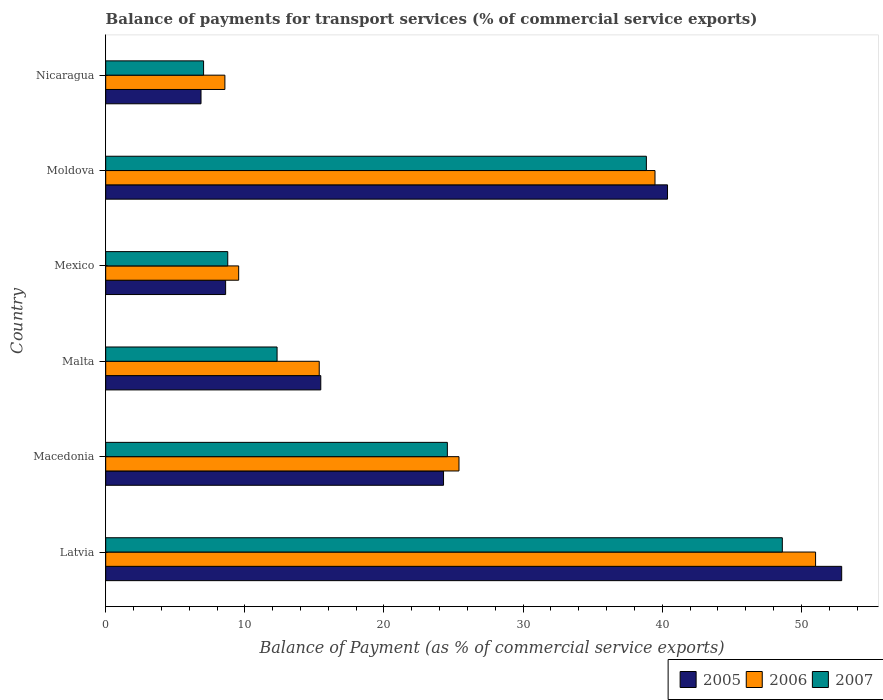How many different coloured bars are there?
Keep it short and to the point. 3. How many groups of bars are there?
Offer a very short reply. 6. Are the number of bars on each tick of the Y-axis equal?
Offer a terse response. Yes. How many bars are there on the 3rd tick from the top?
Your answer should be very brief. 3. How many bars are there on the 6th tick from the bottom?
Provide a succinct answer. 3. What is the balance of payments for transport services in 2006 in Mexico?
Your answer should be compact. 9.56. Across all countries, what is the maximum balance of payments for transport services in 2006?
Provide a short and direct response. 51.02. Across all countries, what is the minimum balance of payments for transport services in 2006?
Ensure brevity in your answer.  8.57. In which country was the balance of payments for transport services in 2005 maximum?
Offer a terse response. Latvia. In which country was the balance of payments for transport services in 2007 minimum?
Offer a terse response. Nicaragua. What is the total balance of payments for transport services in 2006 in the graph?
Give a very brief answer. 149.37. What is the difference between the balance of payments for transport services in 2007 in Malta and that in Moldova?
Offer a terse response. -26.54. What is the difference between the balance of payments for transport services in 2005 in Macedonia and the balance of payments for transport services in 2006 in Mexico?
Ensure brevity in your answer.  14.72. What is the average balance of payments for transport services in 2007 per country?
Your answer should be compact. 23.36. What is the difference between the balance of payments for transport services in 2006 and balance of payments for transport services in 2007 in Malta?
Offer a terse response. 3.03. What is the ratio of the balance of payments for transport services in 2007 in Latvia to that in Macedonia?
Provide a short and direct response. 1.98. Is the difference between the balance of payments for transport services in 2006 in Macedonia and Moldova greater than the difference between the balance of payments for transport services in 2007 in Macedonia and Moldova?
Provide a succinct answer. Yes. What is the difference between the highest and the second highest balance of payments for transport services in 2006?
Ensure brevity in your answer.  11.54. What is the difference between the highest and the lowest balance of payments for transport services in 2006?
Offer a very short reply. 42.46. Is the sum of the balance of payments for transport services in 2006 in Latvia and Moldova greater than the maximum balance of payments for transport services in 2005 across all countries?
Offer a very short reply. Yes. What does the 2nd bar from the bottom in Latvia represents?
Provide a succinct answer. 2006. How many bars are there?
Make the answer very short. 18. What is the difference between two consecutive major ticks on the X-axis?
Offer a very short reply. 10. Are the values on the major ticks of X-axis written in scientific E-notation?
Offer a terse response. No. Does the graph contain any zero values?
Give a very brief answer. No. Where does the legend appear in the graph?
Give a very brief answer. Bottom right. How many legend labels are there?
Keep it short and to the point. 3. How are the legend labels stacked?
Your answer should be compact. Horizontal. What is the title of the graph?
Offer a terse response. Balance of payments for transport services (% of commercial service exports). What is the label or title of the X-axis?
Your response must be concise. Balance of Payment (as % of commercial service exports). What is the label or title of the Y-axis?
Ensure brevity in your answer.  Country. What is the Balance of Payment (as % of commercial service exports) of 2005 in Latvia?
Give a very brief answer. 52.9. What is the Balance of Payment (as % of commercial service exports) of 2006 in Latvia?
Offer a terse response. 51.02. What is the Balance of Payment (as % of commercial service exports) of 2007 in Latvia?
Make the answer very short. 48.63. What is the Balance of Payment (as % of commercial service exports) of 2005 in Macedonia?
Keep it short and to the point. 24.28. What is the Balance of Payment (as % of commercial service exports) of 2006 in Macedonia?
Give a very brief answer. 25.39. What is the Balance of Payment (as % of commercial service exports) in 2007 in Macedonia?
Your answer should be compact. 24.56. What is the Balance of Payment (as % of commercial service exports) in 2005 in Malta?
Provide a succinct answer. 15.46. What is the Balance of Payment (as % of commercial service exports) in 2006 in Malta?
Offer a very short reply. 15.35. What is the Balance of Payment (as % of commercial service exports) of 2007 in Malta?
Offer a terse response. 12.32. What is the Balance of Payment (as % of commercial service exports) of 2005 in Mexico?
Provide a short and direct response. 8.62. What is the Balance of Payment (as % of commercial service exports) in 2006 in Mexico?
Your response must be concise. 9.56. What is the Balance of Payment (as % of commercial service exports) of 2007 in Mexico?
Your response must be concise. 8.77. What is the Balance of Payment (as % of commercial service exports) of 2005 in Moldova?
Your answer should be compact. 40.38. What is the Balance of Payment (as % of commercial service exports) of 2006 in Moldova?
Your answer should be very brief. 39.48. What is the Balance of Payment (as % of commercial service exports) of 2007 in Moldova?
Offer a very short reply. 38.86. What is the Balance of Payment (as % of commercial service exports) in 2005 in Nicaragua?
Offer a terse response. 6.85. What is the Balance of Payment (as % of commercial service exports) of 2006 in Nicaragua?
Give a very brief answer. 8.57. What is the Balance of Payment (as % of commercial service exports) of 2007 in Nicaragua?
Keep it short and to the point. 7.04. Across all countries, what is the maximum Balance of Payment (as % of commercial service exports) in 2005?
Ensure brevity in your answer.  52.9. Across all countries, what is the maximum Balance of Payment (as % of commercial service exports) in 2006?
Keep it short and to the point. 51.02. Across all countries, what is the maximum Balance of Payment (as % of commercial service exports) of 2007?
Make the answer very short. 48.63. Across all countries, what is the minimum Balance of Payment (as % of commercial service exports) in 2005?
Offer a very short reply. 6.85. Across all countries, what is the minimum Balance of Payment (as % of commercial service exports) of 2006?
Your answer should be compact. 8.57. Across all countries, what is the minimum Balance of Payment (as % of commercial service exports) in 2007?
Your answer should be compact. 7.04. What is the total Balance of Payment (as % of commercial service exports) of 2005 in the graph?
Your answer should be very brief. 148.49. What is the total Balance of Payment (as % of commercial service exports) of 2006 in the graph?
Keep it short and to the point. 149.37. What is the total Balance of Payment (as % of commercial service exports) of 2007 in the graph?
Provide a short and direct response. 140.18. What is the difference between the Balance of Payment (as % of commercial service exports) in 2005 in Latvia and that in Macedonia?
Provide a short and direct response. 28.62. What is the difference between the Balance of Payment (as % of commercial service exports) in 2006 in Latvia and that in Macedonia?
Offer a very short reply. 25.63. What is the difference between the Balance of Payment (as % of commercial service exports) of 2007 in Latvia and that in Macedonia?
Ensure brevity in your answer.  24.07. What is the difference between the Balance of Payment (as % of commercial service exports) of 2005 in Latvia and that in Malta?
Your response must be concise. 37.44. What is the difference between the Balance of Payment (as % of commercial service exports) of 2006 in Latvia and that in Malta?
Offer a terse response. 35.67. What is the difference between the Balance of Payment (as % of commercial service exports) of 2007 in Latvia and that in Malta?
Give a very brief answer. 36.31. What is the difference between the Balance of Payment (as % of commercial service exports) in 2005 in Latvia and that in Mexico?
Your answer should be very brief. 44.28. What is the difference between the Balance of Payment (as % of commercial service exports) of 2006 in Latvia and that in Mexico?
Keep it short and to the point. 41.47. What is the difference between the Balance of Payment (as % of commercial service exports) in 2007 in Latvia and that in Mexico?
Offer a very short reply. 39.86. What is the difference between the Balance of Payment (as % of commercial service exports) of 2005 in Latvia and that in Moldova?
Your response must be concise. 12.52. What is the difference between the Balance of Payment (as % of commercial service exports) of 2006 in Latvia and that in Moldova?
Provide a succinct answer. 11.54. What is the difference between the Balance of Payment (as % of commercial service exports) of 2007 in Latvia and that in Moldova?
Offer a very short reply. 9.77. What is the difference between the Balance of Payment (as % of commercial service exports) of 2005 in Latvia and that in Nicaragua?
Your answer should be very brief. 46.05. What is the difference between the Balance of Payment (as % of commercial service exports) in 2006 in Latvia and that in Nicaragua?
Your answer should be compact. 42.46. What is the difference between the Balance of Payment (as % of commercial service exports) of 2007 in Latvia and that in Nicaragua?
Ensure brevity in your answer.  41.6. What is the difference between the Balance of Payment (as % of commercial service exports) of 2005 in Macedonia and that in Malta?
Ensure brevity in your answer.  8.82. What is the difference between the Balance of Payment (as % of commercial service exports) of 2006 in Macedonia and that in Malta?
Your response must be concise. 10.04. What is the difference between the Balance of Payment (as % of commercial service exports) of 2007 in Macedonia and that in Malta?
Keep it short and to the point. 12.24. What is the difference between the Balance of Payment (as % of commercial service exports) of 2005 in Macedonia and that in Mexico?
Give a very brief answer. 15.66. What is the difference between the Balance of Payment (as % of commercial service exports) of 2006 in Macedonia and that in Mexico?
Provide a short and direct response. 15.84. What is the difference between the Balance of Payment (as % of commercial service exports) in 2007 in Macedonia and that in Mexico?
Keep it short and to the point. 15.78. What is the difference between the Balance of Payment (as % of commercial service exports) in 2005 in Macedonia and that in Moldova?
Ensure brevity in your answer.  -16.1. What is the difference between the Balance of Payment (as % of commercial service exports) of 2006 in Macedonia and that in Moldova?
Ensure brevity in your answer.  -14.09. What is the difference between the Balance of Payment (as % of commercial service exports) in 2007 in Macedonia and that in Moldova?
Provide a short and direct response. -14.3. What is the difference between the Balance of Payment (as % of commercial service exports) in 2005 in Macedonia and that in Nicaragua?
Keep it short and to the point. 17.43. What is the difference between the Balance of Payment (as % of commercial service exports) in 2006 in Macedonia and that in Nicaragua?
Provide a short and direct response. 16.83. What is the difference between the Balance of Payment (as % of commercial service exports) of 2007 in Macedonia and that in Nicaragua?
Offer a terse response. 17.52. What is the difference between the Balance of Payment (as % of commercial service exports) in 2005 in Malta and that in Mexico?
Offer a terse response. 6.84. What is the difference between the Balance of Payment (as % of commercial service exports) in 2006 in Malta and that in Mexico?
Your answer should be very brief. 5.79. What is the difference between the Balance of Payment (as % of commercial service exports) of 2007 in Malta and that in Mexico?
Give a very brief answer. 3.54. What is the difference between the Balance of Payment (as % of commercial service exports) of 2005 in Malta and that in Moldova?
Provide a short and direct response. -24.92. What is the difference between the Balance of Payment (as % of commercial service exports) of 2006 in Malta and that in Moldova?
Your answer should be very brief. -24.13. What is the difference between the Balance of Payment (as % of commercial service exports) in 2007 in Malta and that in Moldova?
Keep it short and to the point. -26.54. What is the difference between the Balance of Payment (as % of commercial service exports) of 2005 in Malta and that in Nicaragua?
Your answer should be compact. 8.61. What is the difference between the Balance of Payment (as % of commercial service exports) of 2006 in Malta and that in Nicaragua?
Your response must be concise. 6.78. What is the difference between the Balance of Payment (as % of commercial service exports) in 2007 in Malta and that in Nicaragua?
Your answer should be very brief. 5.28. What is the difference between the Balance of Payment (as % of commercial service exports) of 2005 in Mexico and that in Moldova?
Give a very brief answer. -31.76. What is the difference between the Balance of Payment (as % of commercial service exports) in 2006 in Mexico and that in Moldova?
Provide a succinct answer. -29.92. What is the difference between the Balance of Payment (as % of commercial service exports) of 2007 in Mexico and that in Moldova?
Your response must be concise. -30.09. What is the difference between the Balance of Payment (as % of commercial service exports) of 2005 in Mexico and that in Nicaragua?
Your answer should be very brief. 1.77. What is the difference between the Balance of Payment (as % of commercial service exports) in 2006 in Mexico and that in Nicaragua?
Offer a very short reply. 0.99. What is the difference between the Balance of Payment (as % of commercial service exports) of 2007 in Mexico and that in Nicaragua?
Ensure brevity in your answer.  1.74. What is the difference between the Balance of Payment (as % of commercial service exports) of 2005 in Moldova and that in Nicaragua?
Offer a very short reply. 33.53. What is the difference between the Balance of Payment (as % of commercial service exports) in 2006 in Moldova and that in Nicaragua?
Make the answer very short. 30.91. What is the difference between the Balance of Payment (as % of commercial service exports) of 2007 in Moldova and that in Nicaragua?
Keep it short and to the point. 31.83. What is the difference between the Balance of Payment (as % of commercial service exports) of 2005 in Latvia and the Balance of Payment (as % of commercial service exports) of 2006 in Macedonia?
Provide a short and direct response. 27.51. What is the difference between the Balance of Payment (as % of commercial service exports) in 2005 in Latvia and the Balance of Payment (as % of commercial service exports) in 2007 in Macedonia?
Ensure brevity in your answer.  28.34. What is the difference between the Balance of Payment (as % of commercial service exports) of 2006 in Latvia and the Balance of Payment (as % of commercial service exports) of 2007 in Macedonia?
Provide a short and direct response. 26.47. What is the difference between the Balance of Payment (as % of commercial service exports) in 2005 in Latvia and the Balance of Payment (as % of commercial service exports) in 2006 in Malta?
Keep it short and to the point. 37.55. What is the difference between the Balance of Payment (as % of commercial service exports) in 2005 in Latvia and the Balance of Payment (as % of commercial service exports) in 2007 in Malta?
Offer a very short reply. 40.58. What is the difference between the Balance of Payment (as % of commercial service exports) in 2006 in Latvia and the Balance of Payment (as % of commercial service exports) in 2007 in Malta?
Offer a terse response. 38.7. What is the difference between the Balance of Payment (as % of commercial service exports) of 2005 in Latvia and the Balance of Payment (as % of commercial service exports) of 2006 in Mexico?
Provide a succinct answer. 43.34. What is the difference between the Balance of Payment (as % of commercial service exports) of 2005 in Latvia and the Balance of Payment (as % of commercial service exports) of 2007 in Mexico?
Offer a very short reply. 44.13. What is the difference between the Balance of Payment (as % of commercial service exports) of 2006 in Latvia and the Balance of Payment (as % of commercial service exports) of 2007 in Mexico?
Your answer should be very brief. 42.25. What is the difference between the Balance of Payment (as % of commercial service exports) of 2005 in Latvia and the Balance of Payment (as % of commercial service exports) of 2006 in Moldova?
Keep it short and to the point. 13.42. What is the difference between the Balance of Payment (as % of commercial service exports) in 2005 in Latvia and the Balance of Payment (as % of commercial service exports) in 2007 in Moldova?
Provide a succinct answer. 14.04. What is the difference between the Balance of Payment (as % of commercial service exports) in 2006 in Latvia and the Balance of Payment (as % of commercial service exports) in 2007 in Moldova?
Keep it short and to the point. 12.16. What is the difference between the Balance of Payment (as % of commercial service exports) in 2005 in Latvia and the Balance of Payment (as % of commercial service exports) in 2006 in Nicaragua?
Keep it short and to the point. 44.33. What is the difference between the Balance of Payment (as % of commercial service exports) of 2005 in Latvia and the Balance of Payment (as % of commercial service exports) of 2007 in Nicaragua?
Offer a very short reply. 45.86. What is the difference between the Balance of Payment (as % of commercial service exports) in 2006 in Latvia and the Balance of Payment (as % of commercial service exports) in 2007 in Nicaragua?
Offer a terse response. 43.99. What is the difference between the Balance of Payment (as % of commercial service exports) of 2005 in Macedonia and the Balance of Payment (as % of commercial service exports) of 2006 in Malta?
Ensure brevity in your answer.  8.93. What is the difference between the Balance of Payment (as % of commercial service exports) of 2005 in Macedonia and the Balance of Payment (as % of commercial service exports) of 2007 in Malta?
Keep it short and to the point. 11.96. What is the difference between the Balance of Payment (as % of commercial service exports) of 2006 in Macedonia and the Balance of Payment (as % of commercial service exports) of 2007 in Malta?
Give a very brief answer. 13.07. What is the difference between the Balance of Payment (as % of commercial service exports) of 2005 in Macedonia and the Balance of Payment (as % of commercial service exports) of 2006 in Mexico?
Your answer should be compact. 14.72. What is the difference between the Balance of Payment (as % of commercial service exports) in 2005 in Macedonia and the Balance of Payment (as % of commercial service exports) in 2007 in Mexico?
Your response must be concise. 15.51. What is the difference between the Balance of Payment (as % of commercial service exports) in 2006 in Macedonia and the Balance of Payment (as % of commercial service exports) in 2007 in Mexico?
Offer a terse response. 16.62. What is the difference between the Balance of Payment (as % of commercial service exports) of 2005 in Macedonia and the Balance of Payment (as % of commercial service exports) of 2006 in Moldova?
Offer a very short reply. -15.2. What is the difference between the Balance of Payment (as % of commercial service exports) in 2005 in Macedonia and the Balance of Payment (as % of commercial service exports) in 2007 in Moldova?
Provide a succinct answer. -14.58. What is the difference between the Balance of Payment (as % of commercial service exports) in 2006 in Macedonia and the Balance of Payment (as % of commercial service exports) in 2007 in Moldova?
Make the answer very short. -13.47. What is the difference between the Balance of Payment (as % of commercial service exports) of 2005 in Macedonia and the Balance of Payment (as % of commercial service exports) of 2006 in Nicaragua?
Your answer should be compact. 15.71. What is the difference between the Balance of Payment (as % of commercial service exports) in 2005 in Macedonia and the Balance of Payment (as % of commercial service exports) in 2007 in Nicaragua?
Ensure brevity in your answer.  17.25. What is the difference between the Balance of Payment (as % of commercial service exports) in 2006 in Macedonia and the Balance of Payment (as % of commercial service exports) in 2007 in Nicaragua?
Give a very brief answer. 18.36. What is the difference between the Balance of Payment (as % of commercial service exports) of 2005 in Malta and the Balance of Payment (as % of commercial service exports) of 2006 in Mexico?
Your answer should be very brief. 5.9. What is the difference between the Balance of Payment (as % of commercial service exports) in 2005 in Malta and the Balance of Payment (as % of commercial service exports) in 2007 in Mexico?
Your answer should be compact. 6.69. What is the difference between the Balance of Payment (as % of commercial service exports) of 2006 in Malta and the Balance of Payment (as % of commercial service exports) of 2007 in Mexico?
Your answer should be compact. 6.57. What is the difference between the Balance of Payment (as % of commercial service exports) of 2005 in Malta and the Balance of Payment (as % of commercial service exports) of 2006 in Moldova?
Offer a terse response. -24.02. What is the difference between the Balance of Payment (as % of commercial service exports) of 2005 in Malta and the Balance of Payment (as % of commercial service exports) of 2007 in Moldova?
Your answer should be compact. -23.4. What is the difference between the Balance of Payment (as % of commercial service exports) in 2006 in Malta and the Balance of Payment (as % of commercial service exports) in 2007 in Moldova?
Give a very brief answer. -23.51. What is the difference between the Balance of Payment (as % of commercial service exports) in 2005 in Malta and the Balance of Payment (as % of commercial service exports) in 2006 in Nicaragua?
Offer a terse response. 6.89. What is the difference between the Balance of Payment (as % of commercial service exports) in 2005 in Malta and the Balance of Payment (as % of commercial service exports) in 2007 in Nicaragua?
Ensure brevity in your answer.  8.42. What is the difference between the Balance of Payment (as % of commercial service exports) of 2006 in Malta and the Balance of Payment (as % of commercial service exports) of 2007 in Nicaragua?
Provide a succinct answer. 8.31. What is the difference between the Balance of Payment (as % of commercial service exports) of 2005 in Mexico and the Balance of Payment (as % of commercial service exports) of 2006 in Moldova?
Provide a succinct answer. -30.86. What is the difference between the Balance of Payment (as % of commercial service exports) of 2005 in Mexico and the Balance of Payment (as % of commercial service exports) of 2007 in Moldova?
Provide a succinct answer. -30.24. What is the difference between the Balance of Payment (as % of commercial service exports) of 2006 in Mexico and the Balance of Payment (as % of commercial service exports) of 2007 in Moldova?
Offer a very short reply. -29.3. What is the difference between the Balance of Payment (as % of commercial service exports) of 2005 in Mexico and the Balance of Payment (as % of commercial service exports) of 2006 in Nicaragua?
Your answer should be very brief. 0.05. What is the difference between the Balance of Payment (as % of commercial service exports) in 2005 in Mexico and the Balance of Payment (as % of commercial service exports) in 2007 in Nicaragua?
Offer a very short reply. 1.58. What is the difference between the Balance of Payment (as % of commercial service exports) of 2006 in Mexico and the Balance of Payment (as % of commercial service exports) of 2007 in Nicaragua?
Ensure brevity in your answer.  2.52. What is the difference between the Balance of Payment (as % of commercial service exports) of 2005 in Moldova and the Balance of Payment (as % of commercial service exports) of 2006 in Nicaragua?
Your answer should be very brief. 31.81. What is the difference between the Balance of Payment (as % of commercial service exports) in 2005 in Moldova and the Balance of Payment (as % of commercial service exports) in 2007 in Nicaragua?
Give a very brief answer. 33.34. What is the difference between the Balance of Payment (as % of commercial service exports) in 2006 in Moldova and the Balance of Payment (as % of commercial service exports) in 2007 in Nicaragua?
Your answer should be very brief. 32.44. What is the average Balance of Payment (as % of commercial service exports) of 2005 per country?
Provide a short and direct response. 24.75. What is the average Balance of Payment (as % of commercial service exports) of 2006 per country?
Your response must be concise. 24.89. What is the average Balance of Payment (as % of commercial service exports) in 2007 per country?
Your answer should be very brief. 23.36. What is the difference between the Balance of Payment (as % of commercial service exports) in 2005 and Balance of Payment (as % of commercial service exports) in 2006 in Latvia?
Give a very brief answer. 1.88. What is the difference between the Balance of Payment (as % of commercial service exports) of 2005 and Balance of Payment (as % of commercial service exports) of 2007 in Latvia?
Your answer should be compact. 4.27. What is the difference between the Balance of Payment (as % of commercial service exports) of 2006 and Balance of Payment (as % of commercial service exports) of 2007 in Latvia?
Your answer should be very brief. 2.39. What is the difference between the Balance of Payment (as % of commercial service exports) of 2005 and Balance of Payment (as % of commercial service exports) of 2006 in Macedonia?
Your answer should be very brief. -1.11. What is the difference between the Balance of Payment (as % of commercial service exports) in 2005 and Balance of Payment (as % of commercial service exports) in 2007 in Macedonia?
Give a very brief answer. -0.28. What is the difference between the Balance of Payment (as % of commercial service exports) in 2006 and Balance of Payment (as % of commercial service exports) in 2007 in Macedonia?
Your answer should be very brief. 0.84. What is the difference between the Balance of Payment (as % of commercial service exports) of 2005 and Balance of Payment (as % of commercial service exports) of 2006 in Malta?
Your answer should be very brief. 0.11. What is the difference between the Balance of Payment (as % of commercial service exports) in 2005 and Balance of Payment (as % of commercial service exports) in 2007 in Malta?
Ensure brevity in your answer.  3.14. What is the difference between the Balance of Payment (as % of commercial service exports) in 2006 and Balance of Payment (as % of commercial service exports) in 2007 in Malta?
Provide a succinct answer. 3.03. What is the difference between the Balance of Payment (as % of commercial service exports) of 2005 and Balance of Payment (as % of commercial service exports) of 2006 in Mexico?
Keep it short and to the point. -0.94. What is the difference between the Balance of Payment (as % of commercial service exports) in 2005 and Balance of Payment (as % of commercial service exports) in 2007 in Mexico?
Offer a very short reply. -0.15. What is the difference between the Balance of Payment (as % of commercial service exports) of 2006 and Balance of Payment (as % of commercial service exports) of 2007 in Mexico?
Offer a terse response. 0.78. What is the difference between the Balance of Payment (as % of commercial service exports) of 2005 and Balance of Payment (as % of commercial service exports) of 2006 in Moldova?
Ensure brevity in your answer.  0.9. What is the difference between the Balance of Payment (as % of commercial service exports) of 2005 and Balance of Payment (as % of commercial service exports) of 2007 in Moldova?
Offer a very short reply. 1.52. What is the difference between the Balance of Payment (as % of commercial service exports) in 2006 and Balance of Payment (as % of commercial service exports) in 2007 in Moldova?
Ensure brevity in your answer.  0.62. What is the difference between the Balance of Payment (as % of commercial service exports) in 2005 and Balance of Payment (as % of commercial service exports) in 2006 in Nicaragua?
Provide a succinct answer. -1.72. What is the difference between the Balance of Payment (as % of commercial service exports) in 2005 and Balance of Payment (as % of commercial service exports) in 2007 in Nicaragua?
Give a very brief answer. -0.19. What is the difference between the Balance of Payment (as % of commercial service exports) of 2006 and Balance of Payment (as % of commercial service exports) of 2007 in Nicaragua?
Ensure brevity in your answer.  1.53. What is the ratio of the Balance of Payment (as % of commercial service exports) of 2005 in Latvia to that in Macedonia?
Ensure brevity in your answer.  2.18. What is the ratio of the Balance of Payment (as % of commercial service exports) of 2006 in Latvia to that in Macedonia?
Your answer should be compact. 2.01. What is the ratio of the Balance of Payment (as % of commercial service exports) of 2007 in Latvia to that in Macedonia?
Your response must be concise. 1.98. What is the ratio of the Balance of Payment (as % of commercial service exports) in 2005 in Latvia to that in Malta?
Your answer should be compact. 3.42. What is the ratio of the Balance of Payment (as % of commercial service exports) in 2006 in Latvia to that in Malta?
Provide a succinct answer. 3.32. What is the ratio of the Balance of Payment (as % of commercial service exports) in 2007 in Latvia to that in Malta?
Your response must be concise. 3.95. What is the ratio of the Balance of Payment (as % of commercial service exports) of 2005 in Latvia to that in Mexico?
Keep it short and to the point. 6.14. What is the ratio of the Balance of Payment (as % of commercial service exports) of 2006 in Latvia to that in Mexico?
Your answer should be compact. 5.34. What is the ratio of the Balance of Payment (as % of commercial service exports) in 2007 in Latvia to that in Mexico?
Provide a succinct answer. 5.54. What is the ratio of the Balance of Payment (as % of commercial service exports) of 2005 in Latvia to that in Moldova?
Offer a very short reply. 1.31. What is the ratio of the Balance of Payment (as % of commercial service exports) of 2006 in Latvia to that in Moldova?
Make the answer very short. 1.29. What is the ratio of the Balance of Payment (as % of commercial service exports) in 2007 in Latvia to that in Moldova?
Offer a terse response. 1.25. What is the ratio of the Balance of Payment (as % of commercial service exports) in 2005 in Latvia to that in Nicaragua?
Your response must be concise. 7.72. What is the ratio of the Balance of Payment (as % of commercial service exports) in 2006 in Latvia to that in Nicaragua?
Give a very brief answer. 5.96. What is the ratio of the Balance of Payment (as % of commercial service exports) of 2007 in Latvia to that in Nicaragua?
Your answer should be very brief. 6.91. What is the ratio of the Balance of Payment (as % of commercial service exports) in 2005 in Macedonia to that in Malta?
Provide a short and direct response. 1.57. What is the ratio of the Balance of Payment (as % of commercial service exports) in 2006 in Macedonia to that in Malta?
Make the answer very short. 1.65. What is the ratio of the Balance of Payment (as % of commercial service exports) of 2007 in Macedonia to that in Malta?
Your answer should be very brief. 1.99. What is the ratio of the Balance of Payment (as % of commercial service exports) of 2005 in Macedonia to that in Mexico?
Ensure brevity in your answer.  2.82. What is the ratio of the Balance of Payment (as % of commercial service exports) of 2006 in Macedonia to that in Mexico?
Your answer should be compact. 2.66. What is the ratio of the Balance of Payment (as % of commercial service exports) in 2007 in Macedonia to that in Mexico?
Offer a terse response. 2.8. What is the ratio of the Balance of Payment (as % of commercial service exports) of 2005 in Macedonia to that in Moldova?
Offer a terse response. 0.6. What is the ratio of the Balance of Payment (as % of commercial service exports) of 2006 in Macedonia to that in Moldova?
Provide a succinct answer. 0.64. What is the ratio of the Balance of Payment (as % of commercial service exports) of 2007 in Macedonia to that in Moldova?
Provide a succinct answer. 0.63. What is the ratio of the Balance of Payment (as % of commercial service exports) in 2005 in Macedonia to that in Nicaragua?
Make the answer very short. 3.54. What is the ratio of the Balance of Payment (as % of commercial service exports) of 2006 in Macedonia to that in Nicaragua?
Your answer should be compact. 2.96. What is the ratio of the Balance of Payment (as % of commercial service exports) in 2007 in Macedonia to that in Nicaragua?
Offer a terse response. 3.49. What is the ratio of the Balance of Payment (as % of commercial service exports) of 2005 in Malta to that in Mexico?
Keep it short and to the point. 1.79. What is the ratio of the Balance of Payment (as % of commercial service exports) in 2006 in Malta to that in Mexico?
Your answer should be compact. 1.61. What is the ratio of the Balance of Payment (as % of commercial service exports) in 2007 in Malta to that in Mexico?
Your response must be concise. 1.4. What is the ratio of the Balance of Payment (as % of commercial service exports) in 2005 in Malta to that in Moldova?
Offer a terse response. 0.38. What is the ratio of the Balance of Payment (as % of commercial service exports) in 2006 in Malta to that in Moldova?
Provide a short and direct response. 0.39. What is the ratio of the Balance of Payment (as % of commercial service exports) of 2007 in Malta to that in Moldova?
Your response must be concise. 0.32. What is the ratio of the Balance of Payment (as % of commercial service exports) in 2005 in Malta to that in Nicaragua?
Offer a very short reply. 2.26. What is the ratio of the Balance of Payment (as % of commercial service exports) in 2006 in Malta to that in Nicaragua?
Offer a very short reply. 1.79. What is the ratio of the Balance of Payment (as % of commercial service exports) in 2007 in Malta to that in Nicaragua?
Your answer should be very brief. 1.75. What is the ratio of the Balance of Payment (as % of commercial service exports) of 2005 in Mexico to that in Moldova?
Ensure brevity in your answer.  0.21. What is the ratio of the Balance of Payment (as % of commercial service exports) of 2006 in Mexico to that in Moldova?
Your answer should be very brief. 0.24. What is the ratio of the Balance of Payment (as % of commercial service exports) in 2007 in Mexico to that in Moldova?
Make the answer very short. 0.23. What is the ratio of the Balance of Payment (as % of commercial service exports) of 2005 in Mexico to that in Nicaragua?
Offer a terse response. 1.26. What is the ratio of the Balance of Payment (as % of commercial service exports) of 2006 in Mexico to that in Nicaragua?
Your answer should be very brief. 1.12. What is the ratio of the Balance of Payment (as % of commercial service exports) of 2007 in Mexico to that in Nicaragua?
Offer a terse response. 1.25. What is the ratio of the Balance of Payment (as % of commercial service exports) of 2005 in Moldova to that in Nicaragua?
Your response must be concise. 5.89. What is the ratio of the Balance of Payment (as % of commercial service exports) in 2006 in Moldova to that in Nicaragua?
Provide a succinct answer. 4.61. What is the ratio of the Balance of Payment (as % of commercial service exports) of 2007 in Moldova to that in Nicaragua?
Your answer should be compact. 5.52. What is the difference between the highest and the second highest Balance of Payment (as % of commercial service exports) of 2005?
Your answer should be compact. 12.52. What is the difference between the highest and the second highest Balance of Payment (as % of commercial service exports) in 2006?
Make the answer very short. 11.54. What is the difference between the highest and the second highest Balance of Payment (as % of commercial service exports) in 2007?
Ensure brevity in your answer.  9.77. What is the difference between the highest and the lowest Balance of Payment (as % of commercial service exports) of 2005?
Provide a short and direct response. 46.05. What is the difference between the highest and the lowest Balance of Payment (as % of commercial service exports) of 2006?
Give a very brief answer. 42.46. What is the difference between the highest and the lowest Balance of Payment (as % of commercial service exports) of 2007?
Your answer should be very brief. 41.6. 